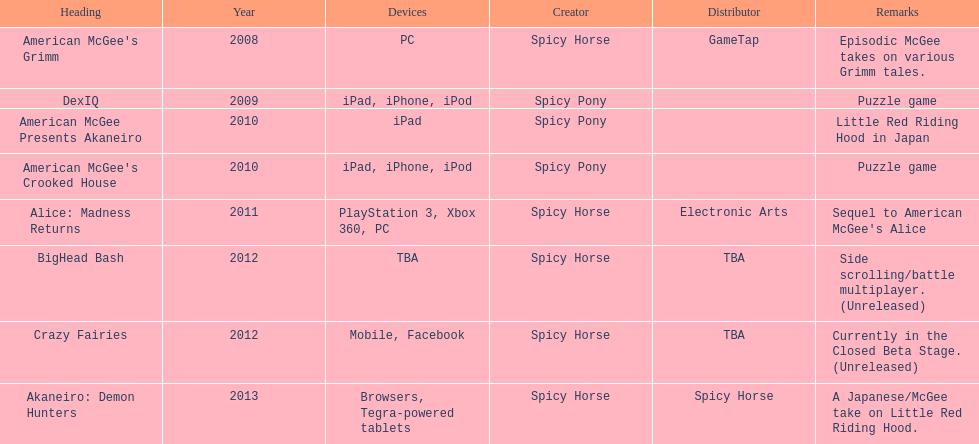How many games did spicy horse develop in total? 5. 